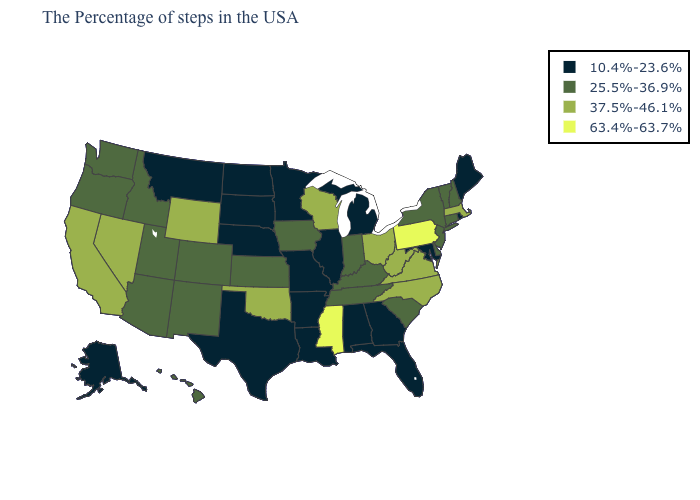What is the value of Idaho?
Be succinct. 25.5%-36.9%. Name the states that have a value in the range 25.5%-36.9%?
Keep it brief. New Hampshire, Vermont, Connecticut, New York, New Jersey, Delaware, South Carolina, Kentucky, Indiana, Tennessee, Iowa, Kansas, Colorado, New Mexico, Utah, Arizona, Idaho, Washington, Oregon, Hawaii. Which states have the lowest value in the USA?
Answer briefly. Maine, Rhode Island, Maryland, Florida, Georgia, Michigan, Alabama, Illinois, Louisiana, Missouri, Arkansas, Minnesota, Nebraska, Texas, South Dakota, North Dakota, Montana, Alaska. What is the value of Oregon?
Short answer required. 25.5%-36.9%. What is the value of North Dakota?
Be succinct. 10.4%-23.6%. Name the states that have a value in the range 25.5%-36.9%?
Keep it brief. New Hampshire, Vermont, Connecticut, New York, New Jersey, Delaware, South Carolina, Kentucky, Indiana, Tennessee, Iowa, Kansas, Colorado, New Mexico, Utah, Arizona, Idaho, Washington, Oregon, Hawaii. What is the lowest value in the South?
Short answer required. 10.4%-23.6%. What is the value of Maine?
Quick response, please. 10.4%-23.6%. Which states have the lowest value in the USA?
Be succinct. Maine, Rhode Island, Maryland, Florida, Georgia, Michigan, Alabama, Illinois, Louisiana, Missouri, Arkansas, Minnesota, Nebraska, Texas, South Dakota, North Dakota, Montana, Alaska. What is the value of Massachusetts?
Give a very brief answer. 37.5%-46.1%. Does the first symbol in the legend represent the smallest category?
Answer briefly. Yes. Is the legend a continuous bar?
Write a very short answer. No. Among the states that border Ohio , does Indiana have the highest value?
Give a very brief answer. No. Name the states that have a value in the range 10.4%-23.6%?
Short answer required. Maine, Rhode Island, Maryland, Florida, Georgia, Michigan, Alabama, Illinois, Louisiana, Missouri, Arkansas, Minnesota, Nebraska, Texas, South Dakota, North Dakota, Montana, Alaska. 